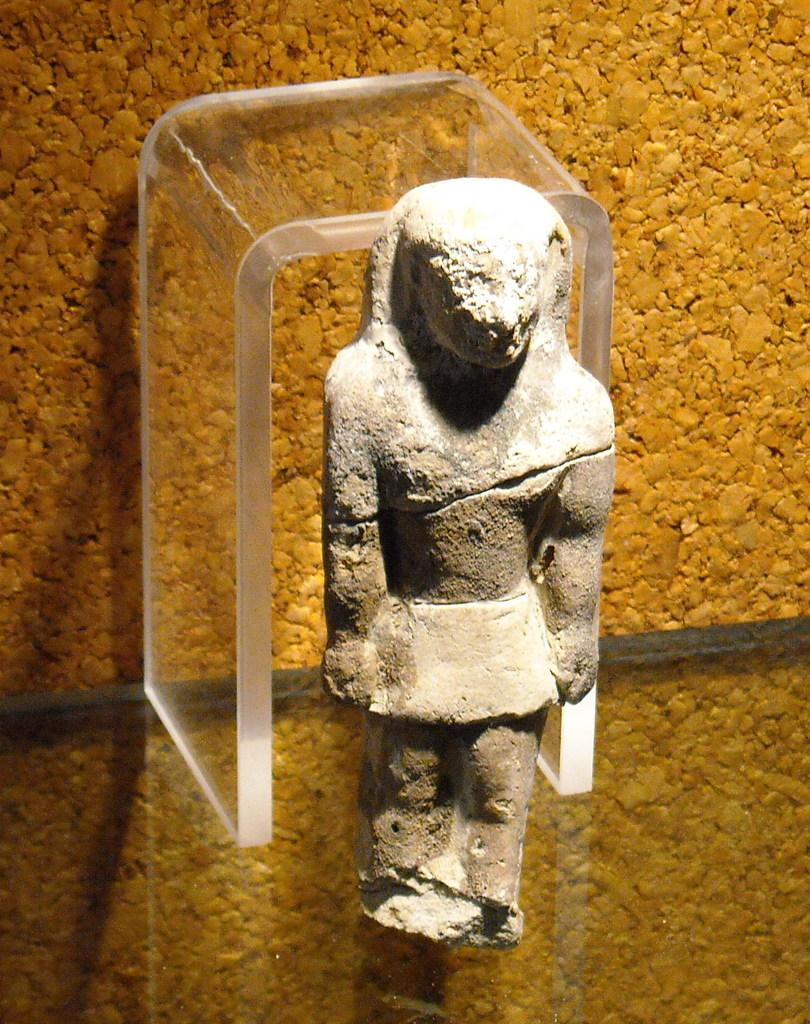What is the main subject of the image? There is a sculpture in the image. What is the sculpture placed on? The sculpture is placed on a glass surface. Is there any other glass element in the image? Yes, there is another piece of glass behind the sculpture. What can be seen in the background of the image? There is a wall in the background of the image. How many chickens are sitting on the sculpture in the image? There are no chickens present in the image; it features a sculpture on a glass surface with another piece of glass behind it and a wall in the background. 